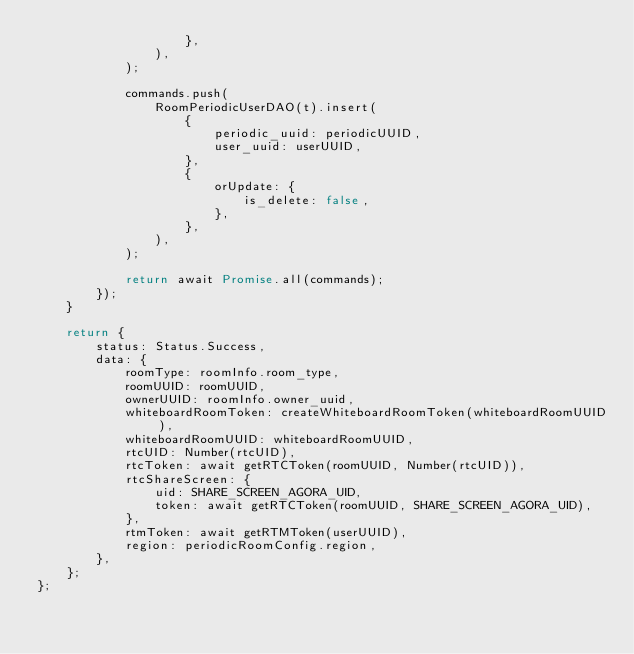<code> <loc_0><loc_0><loc_500><loc_500><_TypeScript_>                    },
                ),
            );

            commands.push(
                RoomPeriodicUserDAO(t).insert(
                    {
                        periodic_uuid: periodicUUID,
                        user_uuid: userUUID,
                    },
                    {
                        orUpdate: {
                            is_delete: false,
                        },
                    },
                ),
            );

            return await Promise.all(commands);
        });
    }

    return {
        status: Status.Success,
        data: {
            roomType: roomInfo.room_type,
            roomUUID: roomUUID,
            ownerUUID: roomInfo.owner_uuid,
            whiteboardRoomToken: createWhiteboardRoomToken(whiteboardRoomUUID),
            whiteboardRoomUUID: whiteboardRoomUUID,
            rtcUID: Number(rtcUID),
            rtcToken: await getRTCToken(roomUUID, Number(rtcUID)),
            rtcShareScreen: {
                uid: SHARE_SCREEN_AGORA_UID,
                token: await getRTCToken(roomUUID, SHARE_SCREEN_AGORA_UID),
            },
            rtmToken: await getRTMToken(userUUID),
            region: periodicRoomConfig.region,
        },
    };
};
</code> 